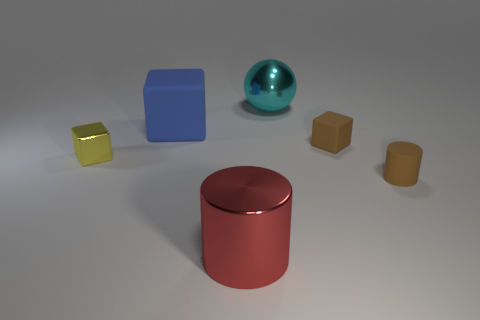Are there any patterns or consistencies in the arrangement of objects? Yes, there's a clear sorting by shape, with cubes on the left and cylinders on the right. There's also a gradation in sizes from smaller to larger as you look from the tiny yellow cube to the larger blue cube and then to the cylinders.  What can you infer about the light source in the scene? The shadows cast by the objects and the highlights on the reflective surfaces suggest a single diffuse light source located above and to the right of the scene. 